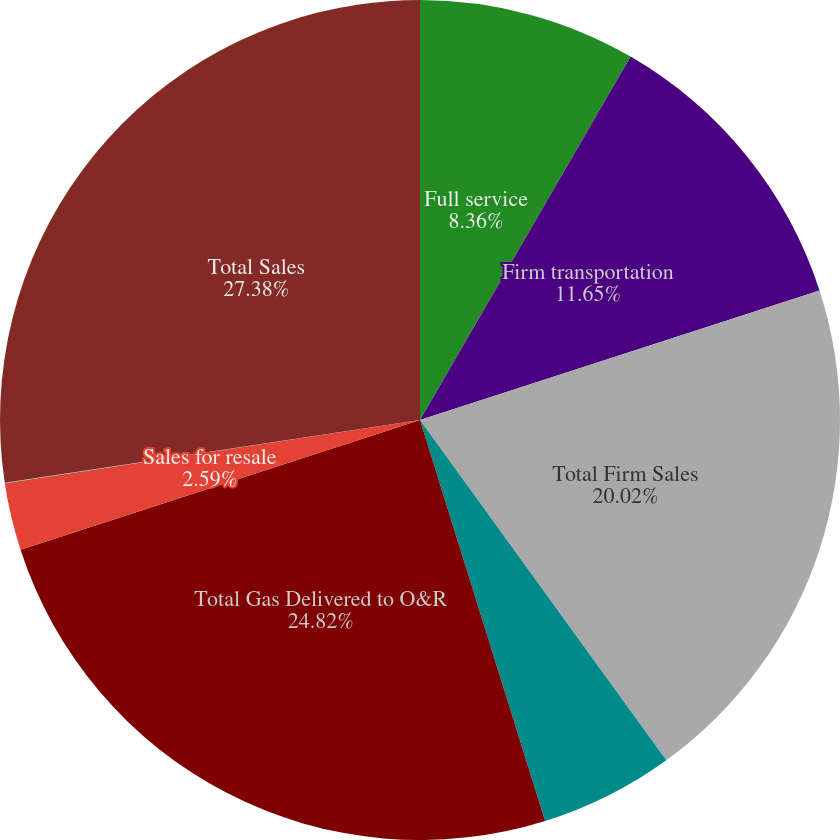Convert chart to OTSL. <chart><loc_0><loc_0><loc_500><loc_500><pie_chart><fcel>Full service<fcel>Firm transportation<fcel>Total Firm Sales<fcel>Interruptible Sales<fcel>Total Gas Delivered to O&R<fcel>Sales for resale<fcel>Sales to electric generating<fcel>Total Sales<nl><fcel>8.36%<fcel>11.65%<fcel>20.02%<fcel>5.16%<fcel>24.82%<fcel>2.59%<fcel>0.02%<fcel>27.39%<nl></chart> 